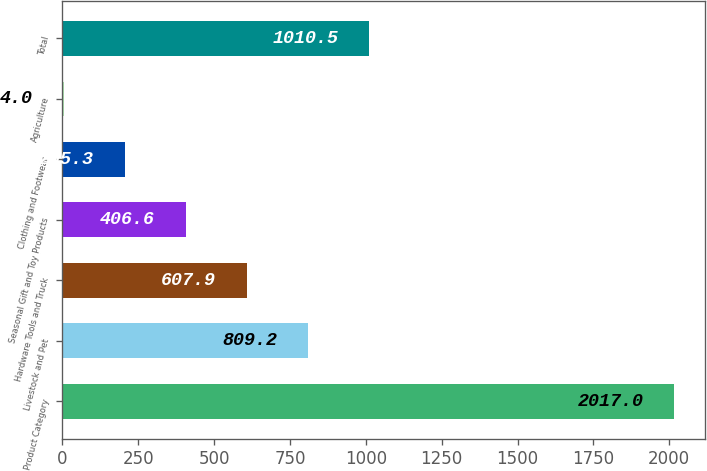Convert chart. <chart><loc_0><loc_0><loc_500><loc_500><bar_chart><fcel>Product Category<fcel>Livestock and Pet<fcel>Hardware Tools and Truck<fcel>Seasonal Gift and Toy Products<fcel>Clothing and Footwear<fcel>Agriculture<fcel>Total<nl><fcel>2017<fcel>809.2<fcel>607.9<fcel>406.6<fcel>205.3<fcel>4<fcel>1010.5<nl></chart> 